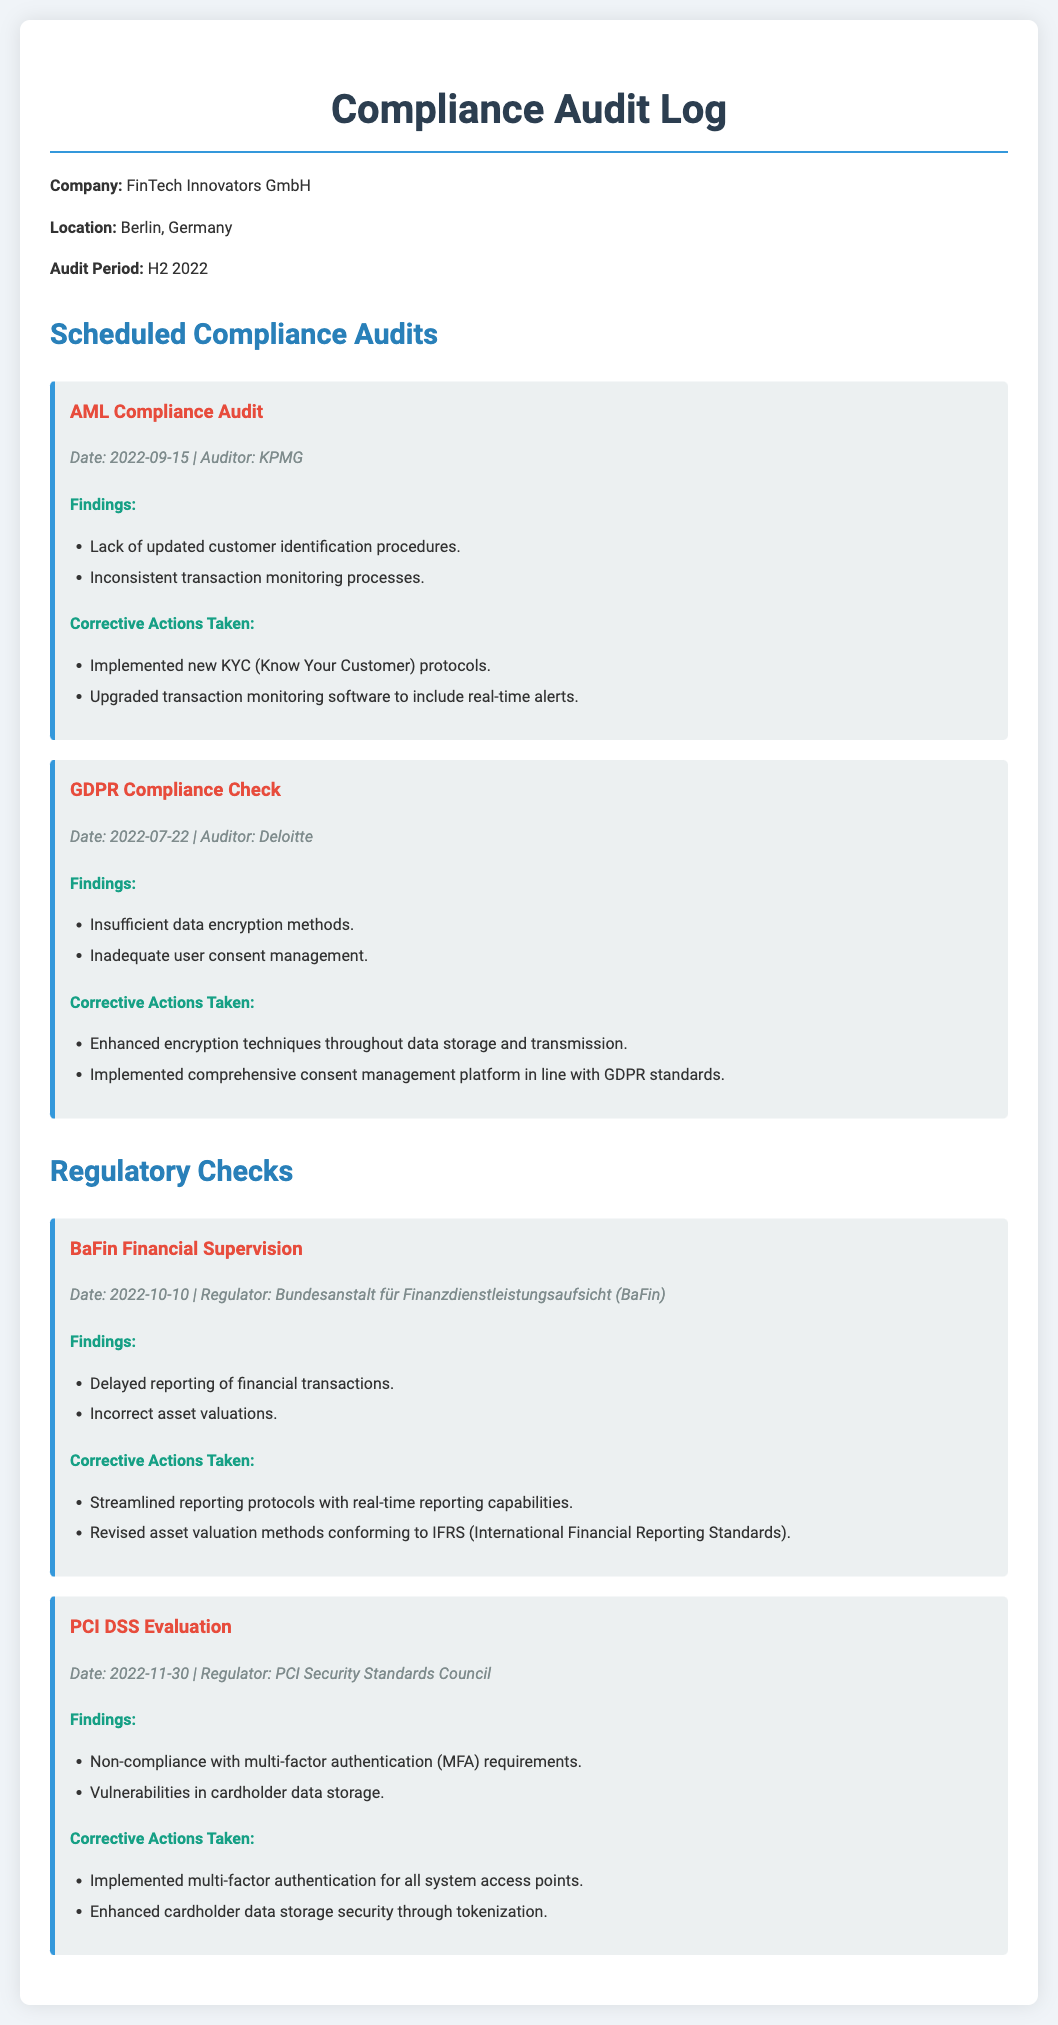What was the date of the AML Compliance Audit? The date is specifically mentioned in the audit section for AML Compliance Audit.
Answer: 2022-09-15 Who conducted the GDPR Compliance Check? The auditor's name for the GDPR Compliance Check is provided in the document.
Answer: Deloitte What were the findings related to data encryption in the GDPR Compliance Check? The findings detail specific issues that were uncovered during the check, including encryption.
Answer: Insufficient data encryption methods What corrective action was taken regarding asset valuations? The document specifies the corrective actions taken, including revisions to asset valuation methods.
Answer: Revised asset valuation methods conforming to IFRS What was the date for the PCI DSS Evaluation? The date can be found listed in the regulatory checks for the PCI DSS Evaluation.
Answer: 2022-11-30 How many compliance audits were listed in the document? The total number of compliance audits will be gathered by counting the relevant sections in the document.
Answer: 2 What corrective action was implemented to address multi-factor authentication requirements? The document outlines specific actions taken to enhance security measures regarding multi-factor authentication.
Answer: Implemented multi-factor authentication for all system access points Which regulator conducted the financial supervision check? The name of the regulator responsible for the financial supervision check is provided in the document.
Answer: Bundesanstalt für Finanzdienstleistungsaufsicht (BaFin) 